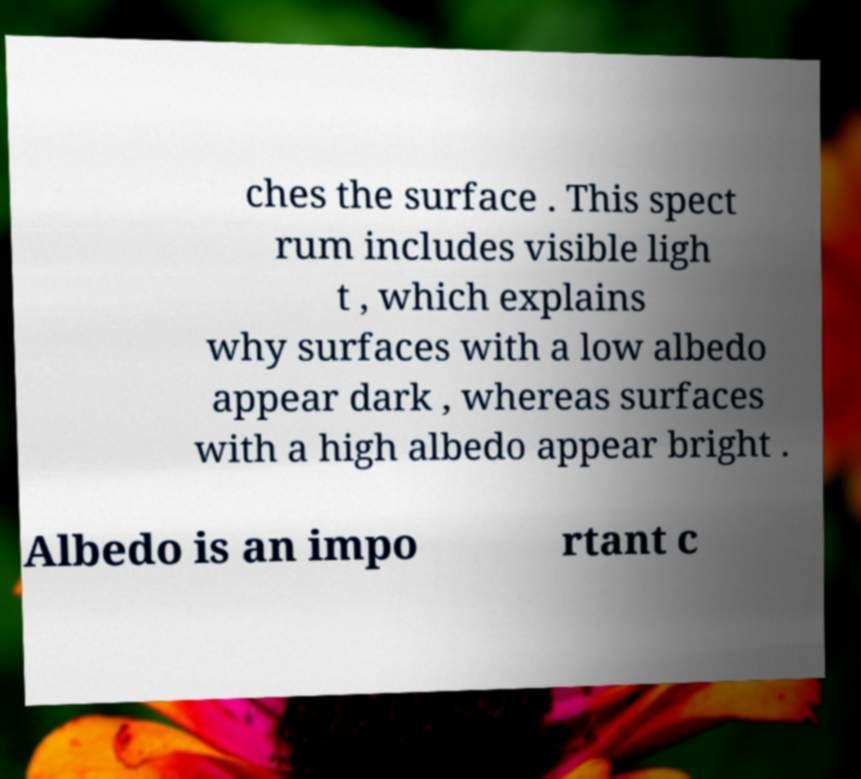Could you assist in decoding the text presented in this image and type it out clearly? ches the surface . This spect rum includes visible ligh t , which explains why surfaces with a low albedo appear dark , whereas surfaces with a high albedo appear bright . Albedo is an impo rtant c 